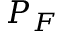Convert formula to latex. <formula><loc_0><loc_0><loc_500><loc_500>P _ { F }</formula> 